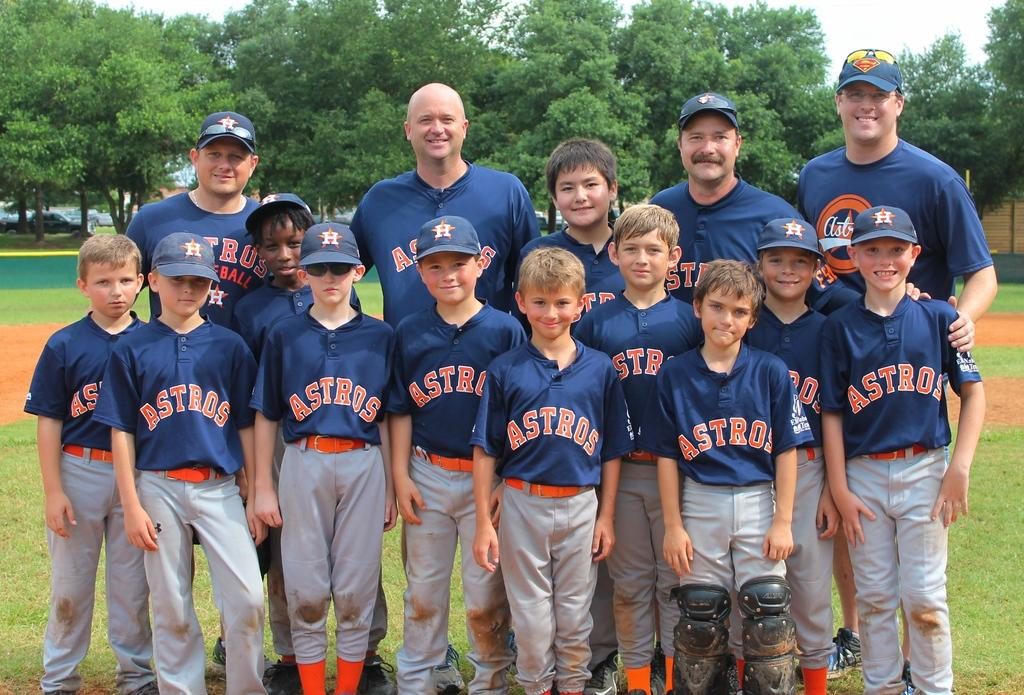Provide a one-sentence caption for the provided image. A baseball team named the Astros posing for a team photo. 